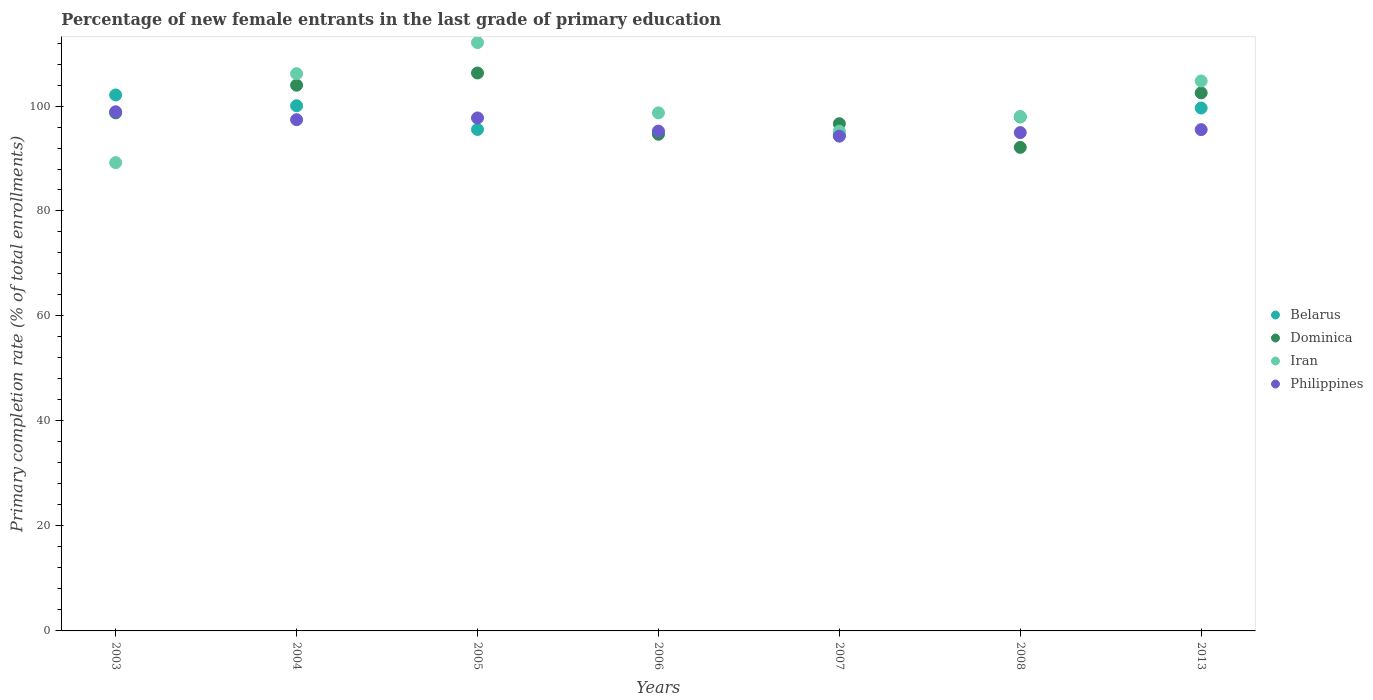How many different coloured dotlines are there?
Keep it short and to the point. 4. Is the number of dotlines equal to the number of legend labels?
Offer a terse response. Yes. What is the percentage of new female entrants in Dominica in 2013?
Offer a terse response. 102.5. Across all years, what is the maximum percentage of new female entrants in Belarus?
Your answer should be compact. 102.11. Across all years, what is the minimum percentage of new female entrants in Belarus?
Provide a succinct answer. 94.45. In which year was the percentage of new female entrants in Philippines minimum?
Make the answer very short. 2007. What is the total percentage of new female entrants in Dominica in the graph?
Offer a very short reply. 694.84. What is the difference between the percentage of new female entrants in Iran in 2004 and that in 2005?
Provide a short and direct response. -5.92. What is the difference between the percentage of new female entrants in Iran in 2013 and the percentage of new female entrants in Belarus in 2003?
Your response must be concise. 2.67. What is the average percentage of new female entrants in Dominica per year?
Your answer should be compact. 99.26. In the year 2013, what is the difference between the percentage of new female entrants in Iran and percentage of new female entrants in Philippines?
Provide a succinct answer. 9.27. In how many years, is the percentage of new female entrants in Dominica greater than 28 %?
Give a very brief answer. 7. What is the ratio of the percentage of new female entrants in Dominica in 2006 to that in 2013?
Ensure brevity in your answer.  0.92. Is the difference between the percentage of new female entrants in Iran in 2004 and 2007 greater than the difference between the percentage of new female entrants in Philippines in 2004 and 2007?
Provide a succinct answer. Yes. What is the difference between the highest and the second highest percentage of new female entrants in Iran?
Your response must be concise. 5.92. What is the difference between the highest and the lowest percentage of new female entrants in Belarus?
Offer a very short reply. 7.65. In how many years, is the percentage of new female entrants in Philippines greater than the average percentage of new female entrants in Philippines taken over all years?
Provide a short and direct response. 3. Is the sum of the percentage of new female entrants in Philippines in 2004 and 2007 greater than the maximum percentage of new female entrants in Iran across all years?
Offer a terse response. Yes. Is it the case that in every year, the sum of the percentage of new female entrants in Philippines and percentage of new female entrants in Belarus  is greater than the percentage of new female entrants in Iran?
Offer a terse response. Yes. How many dotlines are there?
Keep it short and to the point. 4. Are the values on the major ticks of Y-axis written in scientific E-notation?
Provide a succinct answer. No. How are the legend labels stacked?
Provide a short and direct response. Vertical. What is the title of the graph?
Ensure brevity in your answer.  Percentage of new female entrants in the last grade of primary education. Does "Belize" appear as one of the legend labels in the graph?
Keep it short and to the point. No. What is the label or title of the Y-axis?
Ensure brevity in your answer.  Primary completion rate (% of total enrollments). What is the Primary completion rate (% of total enrollments) of Belarus in 2003?
Your answer should be compact. 102.11. What is the Primary completion rate (% of total enrollments) of Dominica in 2003?
Ensure brevity in your answer.  98.7. What is the Primary completion rate (% of total enrollments) in Iran in 2003?
Your answer should be very brief. 89.22. What is the Primary completion rate (% of total enrollments) in Philippines in 2003?
Offer a very short reply. 98.9. What is the Primary completion rate (% of total enrollments) of Belarus in 2004?
Keep it short and to the point. 100.05. What is the Primary completion rate (% of total enrollments) of Dominica in 2004?
Your answer should be very brief. 103.97. What is the Primary completion rate (% of total enrollments) of Iran in 2004?
Keep it short and to the point. 106.16. What is the Primary completion rate (% of total enrollments) of Philippines in 2004?
Your answer should be very brief. 97.39. What is the Primary completion rate (% of total enrollments) in Belarus in 2005?
Keep it short and to the point. 95.53. What is the Primary completion rate (% of total enrollments) of Dominica in 2005?
Provide a succinct answer. 106.29. What is the Primary completion rate (% of total enrollments) of Iran in 2005?
Provide a short and direct response. 112.09. What is the Primary completion rate (% of total enrollments) in Philippines in 2005?
Your response must be concise. 97.73. What is the Primary completion rate (% of total enrollments) in Belarus in 2006?
Keep it short and to the point. 94.92. What is the Primary completion rate (% of total enrollments) in Dominica in 2006?
Keep it short and to the point. 94.62. What is the Primary completion rate (% of total enrollments) of Iran in 2006?
Offer a terse response. 98.69. What is the Primary completion rate (% of total enrollments) of Philippines in 2006?
Give a very brief answer. 95.22. What is the Primary completion rate (% of total enrollments) in Belarus in 2007?
Your response must be concise. 94.45. What is the Primary completion rate (% of total enrollments) in Dominica in 2007?
Provide a succinct answer. 96.63. What is the Primary completion rate (% of total enrollments) in Iran in 2007?
Ensure brevity in your answer.  95.21. What is the Primary completion rate (% of total enrollments) in Philippines in 2007?
Ensure brevity in your answer.  94.26. What is the Primary completion rate (% of total enrollments) of Belarus in 2008?
Provide a short and direct response. 97.92. What is the Primary completion rate (% of total enrollments) of Dominica in 2008?
Your answer should be compact. 92.12. What is the Primary completion rate (% of total enrollments) of Iran in 2008?
Your answer should be compact. 98. What is the Primary completion rate (% of total enrollments) of Philippines in 2008?
Provide a succinct answer. 94.93. What is the Primary completion rate (% of total enrollments) in Belarus in 2013?
Offer a terse response. 99.62. What is the Primary completion rate (% of total enrollments) in Dominica in 2013?
Give a very brief answer. 102.5. What is the Primary completion rate (% of total enrollments) in Iran in 2013?
Provide a succinct answer. 104.77. What is the Primary completion rate (% of total enrollments) of Philippines in 2013?
Offer a terse response. 95.5. Across all years, what is the maximum Primary completion rate (% of total enrollments) of Belarus?
Your answer should be compact. 102.11. Across all years, what is the maximum Primary completion rate (% of total enrollments) of Dominica?
Offer a very short reply. 106.29. Across all years, what is the maximum Primary completion rate (% of total enrollments) of Iran?
Make the answer very short. 112.09. Across all years, what is the maximum Primary completion rate (% of total enrollments) in Philippines?
Ensure brevity in your answer.  98.9. Across all years, what is the minimum Primary completion rate (% of total enrollments) in Belarus?
Keep it short and to the point. 94.45. Across all years, what is the minimum Primary completion rate (% of total enrollments) in Dominica?
Ensure brevity in your answer.  92.12. Across all years, what is the minimum Primary completion rate (% of total enrollments) in Iran?
Your response must be concise. 89.22. Across all years, what is the minimum Primary completion rate (% of total enrollments) of Philippines?
Make the answer very short. 94.26. What is the total Primary completion rate (% of total enrollments) in Belarus in the graph?
Ensure brevity in your answer.  684.59. What is the total Primary completion rate (% of total enrollments) of Dominica in the graph?
Make the answer very short. 694.84. What is the total Primary completion rate (% of total enrollments) in Iran in the graph?
Make the answer very short. 704.14. What is the total Primary completion rate (% of total enrollments) in Philippines in the graph?
Keep it short and to the point. 673.94. What is the difference between the Primary completion rate (% of total enrollments) of Belarus in 2003 and that in 2004?
Your answer should be very brief. 2.06. What is the difference between the Primary completion rate (% of total enrollments) in Dominica in 2003 and that in 2004?
Offer a very short reply. -5.27. What is the difference between the Primary completion rate (% of total enrollments) of Iran in 2003 and that in 2004?
Provide a succinct answer. -16.95. What is the difference between the Primary completion rate (% of total enrollments) of Philippines in 2003 and that in 2004?
Give a very brief answer. 1.51. What is the difference between the Primary completion rate (% of total enrollments) of Belarus in 2003 and that in 2005?
Your response must be concise. 6.57. What is the difference between the Primary completion rate (% of total enrollments) in Dominica in 2003 and that in 2005?
Offer a very short reply. -7.59. What is the difference between the Primary completion rate (% of total enrollments) in Iran in 2003 and that in 2005?
Your response must be concise. -22.87. What is the difference between the Primary completion rate (% of total enrollments) of Philippines in 2003 and that in 2005?
Give a very brief answer. 1.17. What is the difference between the Primary completion rate (% of total enrollments) in Belarus in 2003 and that in 2006?
Make the answer very short. 7.19. What is the difference between the Primary completion rate (% of total enrollments) of Dominica in 2003 and that in 2006?
Your response must be concise. 4.08. What is the difference between the Primary completion rate (% of total enrollments) of Iran in 2003 and that in 2006?
Your response must be concise. -9.48. What is the difference between the Primary completion rate (% of total enrollments) of Philippines in 2003 and that in 2006?
Your answer should be compact. 3.68. What is the difference between the Primary completion rate (% of total enrollments) of Belarus in 2003 and that in 2007?
Your answer should be compact. 7.65. What is the difference between the Primary completion rate (% of total enrollments) of Dominica in 2003 and that in 2007?
Give a very brief answer. 2.07. What is the difference between the Primary completion rate (% of total enrollments) of Iran in 2003 and that in 2007?
Provide a short and direct response. -5.99. What is the difference between the Primary completion rate (% of total enrollments) of Philippines in 2003 and that in 2007?
Offer a terse response. 4.64. What is the difference between the Primary completion rate (% of total enrollments) of Belarus in 2003 and that in 2008?
Offer a terse response. 4.19. What is the difference between the Primary completion rate (% of total enrollments) in Dominica in 2003 and that in 2008?
Make the answer very short. 6.58. What is the difference between the Primary completion rate (% of total enrollments) in Iran in 2003 and that in 2008?
Provide a short and direct response. -8.79. What is the difference between the Primary completion rate (% of total enrollments) in Philippines in 2003 and that in 2008?
Offer a very short reply. 3.97. What is the difference between the Primary completion rate (% of total enrollments) of Belarus in 2003 and that in 2013?
Ensure brevity in your answer.  2.49. What is the difference between the Primary completion rate (% of total enrollments) in Dominica in 2003 and that in 2013?
Your answer should be compact. -3.81. What is the difference between the Primary completion rate (% of total enrollments) in Iran in 2003 and that in 2013?
Make the answer very short. -15.56. What is the difference between the Primary completion rate (% of total enrollments) in Philippines in 2003 and that in 2013?
Offer a very short reply. 3.4. What is the difference between the Primary completion rate (% of total enrollments) in Belarus in 2004 and that in 2005?
Your answer should be very brief. 4.51. What is the difference between the Primary completion rate (% of total enrollments) of Dominica in 2004 and that in 2005?
Keep it short and to the point. -2.33. What is the difference between the Primary completion rate (% of total enrollments) in Iran in 2004 and that in 2005?
Provide a short and direct response. -5.92. What is the difference between the Primary completion rate (% of total enrollments) of Philippines in 2004 and that in 2005?
Give a very brief answer. -0.34. What is the difference between the Primary completion rate (% of total enrollments) in Belarus in 2004 and that in 2006?
Provide a succinct answer. 5.13. What is the difference between the Primary completion rate (% of total enrollments) of Dominica in 2004 and that in 2006?
Your response must be concise. 9.35. What is the difference between the Primary completion rate (% of total enrollments) of Iran in 2004 and that in 2006?
Your answer should be very brief. 7.47. What is the difference between the Primary completion rate (% of total enrollments) in Philippines in 2004 and that in 2006?
Keep it short and to the point. 2.17. What is the difference between the Primary completion rate (% of total enrollments) in Belarus in 2004 and that in 2007?
Your answer should be very brief. 5.59. What is the difference between the Primary completion rate (% of total enrollments) of Dominica in 2004 and that in 2007?
Offer a terse response. 7.33. What is the difference between the Primary completion rate (% of total enrollments) in Iran in 2004 and that in 2007?
Offer a very short reply. 10.96. What is the difference between the Primary completion rate (% of total enrollments) in Philippines in 2004 and that in 2007?
Your answer should be compact. 3.14. What is the difference between the Primary completion rate (% of total enrollments) of Belarus in 2004 and that in 2008?
Give a very brief answer. 2.13. What is the difference between the Primary completion rate (% of total enrollments) in Dominica in 2004 and that in 2008?
Make the answer very short. 11.84. What is the difference between the Primary completion rate (% of total enrollments) of Iran in 2004 and that in 2008?
Keep it short and to the point. 8.16. What is the difference between the Primary completion rate (% of total enrollments) in Philippines in 2004 and that in 2008?
Your answer should be very brief. 2.46. What is the difference between the Primary completion rate (% of total enrollments) in Belarus in 2004 and that in 2013?
Offer a terse response. 0.43. What is the difference between the Primary completion rate (% of total enrollments) of Dominica in 2004 and that in 2013?
Provide a short and direct response. 1.46. What is the difference between the Primary completion rate (% of total enrollments) of Iran in 2004 and that in 2013?
Your answer should be compact. 1.39. What is the difference between the Primary completion rate (% of total enrollments) in Philippines in 2004 and that in 2013?
Provide a short and direct response. 1.89. What is the difference between the Primary completion rate (% of total enrollments) of Belarus in 2005 and that in 2006?
Your answer should be very brief. 0.61. What is the difference between the Primary completion rate (% of total enrollments) in Dominica in 2005 and that in 2006?
Ensure brevity in your answer.  11.68. What is the difference between the Primary completion rate (% of total enrollments) in Iran in 2005 and that in 2006?
Your response must be concise. 13.39. What is the difference between the Primary completion rate (% of total enrollments) in Philippines in 2005 and that in 2006?
Your response must be concise. 2.51. What is the difference between the Primary completion rate (% of total enrollments) in Belarus in 2005 and that in 2007?
Offer a terse response. 1.08. What is the difference between the Primary completion rate (% of total enrollments) in Dominica in 2005 and that in 2007?
Offer a terse response. 9.66. What is the difference between the Primary completion rate (% of total enrollments) of Iran in 2005 and that in 2007?
Give a very brief answer. 16.88. What is the difference between the Primary completion rate (% of total enrollments) in Philippines in 2005 and that in 2007?
Provide a short and direct response. 3.47. What is the difference between the Primary completion rate (% of total enrollments) in Belarus in 2005 and that in 2008?
Your answer should be very brief. -2.39. What is the difference between the Primary completion rate (% of total enrollments) in Dominica in 2005 and that in 2008?
Provide a short and direct response. 14.17. What is the difference between the Primary completion rate (% of total enrollments) in Iran in 2005 and that in 2008?
Keep it short and to the point. 14.08. What is the difference between the Primary completion rate (% of total enrollments) in Philippines in 2005 and that in 2008?
Keep it short and to the point. 2.79. What is the difference between the Primary completion rate (% of total enrollments) in Belarus in 2005 and that in 2013?
Offer a terse response. -4.08. What is the difference between the Primary completion rate (% of total enrollments) in Dominica in 2005 and that in 2013?
Your answer should be very brief. 3.79. What is the difference between the Primary completion rate (% of total enrollments) in Iran in 2005 and that in 2013?
Ensure brevity in your answer.  7.31. What is the difference between the Primary completion rate (% of total enrollments) of Philippines in 2005 and that in 2013?
Your response must be concise. 2.23. What is the difference between the Primary completion rate (% of total enrollments) of Belarus in 2006 and that in 2007?
Your answer should be very brief. 0.47. What is the difference between the Primary completion rate (% of total enrollments) in Dominica in 2006 and that in 2007?
Offer a very short reply. -2.01. What is the difference between the Primary completion rate (% of total enrollments) of Iran in 2006 and that in 2007?
Your answer should be very brief. 3.49. What is the difference between the Primary completion rate (% of total enrollments) in Philippines in 2006 and that in 2007?
Your response must be concise. 0.96. What is the difference between the Primary completion rate (% of total enrollments) in Belarus in 2006 and that in 2008?
Make the answer very short. -3. What is the difference between the Primary completion rate (% of total enrollments) of Dominica in 2006 and that in 2008?
Keep it short and to the point. 2.5. What is the difference between the Primary completion rate (% of total enrollments) of Iran in 2006 and that in 2008?
Provide a succinct answer. 0.69. What is the difference between the Primary completion rate (% of total enrollments) in Philippines in 2006 and that in 2008?
Ensure brevity in your answer.  0.29. What is the difference between the Primary completion rate (% of total enrollments) of Belarus in 2006 and that in 2013?
Your answer should be compact. -4.7. What is the difference between the Primary completion rate (% of total enrollments) of Dominica in 2006 and that in 2013?
Offer a very short reply. -7.89. What is the difference between the Primary completion rate (% of total enrollments) in Iran in 2006 and that in 2013?
Offer a very short reply. -6.08. What is the difference between the Primary completion rate (% of total enrollments) in Philippines in 2006 and that in 2013?
Ensure brevity in your answer.  -0.28. What is the difference between the Primary completion rate (% of total enrollments) in Belarus in 2007 and that in 2008?
Ensure brevity in your answer.  -3.47. What is the difference between the Primary completion rate (% of total enrollments) of Dominica in 2007 and that in 2008?
Provide a short and direct response. 4.51. What is the difference between the Primary completion rate (% of total enrollments) in Iran in 2007 and that in 2008?
Give a very brief answer. -2.8. What is the difference between the Primary completion rate (% of total enrollments) in Philippines in 2007 and that in 2008?
Make the answer very short. -0.68. What is the difference between the Primary completion rate (% of total enrollments) in Belarus in 2007 and that in 2013?
Your answer should be compact. -5.16. What is the difference between the Primary completion rate (% of total enrollments) in Dominica in 2007 and that in 2013?
Make the answer very short. -5.87. What is the difference between the Primary completion rate (% of total enrollments) of Iran in 2007 and that in 2013?
Your answer should be compact. -9.57. What is the difference between the Primary completion rate (% of total enrollments) of Philippines in 2007 and that in 2013?
Provide a short and direct response. -1.24. What is the difference between the Primary completion rate (% of total enrollments) in Belarus in 2008 and that in 2013?
Offer a very short reply. -1.7. What is the difference between the Primary completion rate (% of total enrollments) of Dominica in 2008 and that in 2013?
Offer a very short reply. -10.38. What is the difference between the Primary completion rate (% of total enrollments) of Iran in 2008 and that in 2013?
Your answer should be compact. -6.77. What is the difference between the Primary completion rate (% of total enrollments) of Philippines in 2008 and that in 2013?
Your answer should be compact. -0.57. What is the difference between the Primary completion rate (% of total enrollments) in Belarus in 2003 and the Primary completion rate (% of total enrollments) in Dominica in 2004?
Offer a very short reply. -1.86. What is the difference between the Primary completion rate (% of total enrollments) in Belarus in 2003 and the Primary completion rate (% of total enrollments) in Iran in 2004?
Give a very brief answer. -4.06. What is the difference between the Primary completion rate (% of total enrollments) of Belarus in 2003 and the Primary completion rate (% of total enrollments) of Philippines in 2004?
Your answer should be compact. 4.71. What is the difference between the Primary completion rate (% of total enrollments) of Dominica in 2003 and the Primary completion rate (% of total enrollments) of Iran in 2004?
Keep it short and to the point. -7.46. What is the difference between the Primary completion rate (% of total enrollments) of Dominica in 2003 and the Primary completion rate (% of total enrollments) of Philippines in 2004?
Provide a succinct answer. 1.31. What is the difference between the Primary completion rate (% of total enrollments) in Iran in 2003 and the Primary completion rate (% of total enrollments) in Philippines in 2004?
Ensure brevity in your answer.  -8.18. What is the difference between the Primary completion rate (% of total enrollments) of Belarus in 2003 and the Primary completion rate (% of total enrollments) of Dominica in 2005?
Your answer should be very brief. -4.19. What is the difference between the Primary completion rate (% of total enrollments) in Belarus in 2003 and the Primary completion rate (% of total enrollments) in Iran in 2005?
Your response must be concise. -9.98. What is the difference between the Primary completion rate (% of total enrollments) of Belarus in 2003 and the Primary completion rate (% of total enrollments) of Philippines in 2005?
Offer a terse response. 4.38. What is the difference between the Primary completion rate (% of total enrollments) of Dominica in 2003 and the Primary completion rate (% of total enrollments) of Iran in 2005?
Your answer should be compact. -13.39. What is the difference between the Primary completion rate (% of total enrollments) in Dominica in 2003 and the Primary completion rate (% of total enrollments) in Philippines in 2005?
Ensure brevity in your answer.  0.97. What is the difference between the Primary completion rate (% of total enrollments) in Iran in 2003 and the Primary completion rate (% of total enrollments) in Philippines in 2005?
Offer a very short reply. -8.51. What is the difference between the Primary completion rate (% of total enrollments) in Belarus in 2003 and the Primary completion rate (% of total enrollments) in Dominica in 2006?
Give a very brief answer. 7.49. What is the difference between the Primary completion rate (% of total enrollments) of Belarus in 2003 and the Primary completion rate (% of total enrollments) of Iran in 2006?
Provide a succinct answer. 3.41. What is the difference between the Primary completion rate (% of total enrollments) in Belarus in 2003 and the Primary completion rate (% of total enrollments) in Philippines in 2006?
Your answer should be compact. 6.88. What is the difference between the Primary completion rate (% of total enrollments) of Dominica in 2003 and the Primary completion rate (% of total enrollments) of Iran in 2006?
Your answer should be very brief. 0.01. What is the difference between the Primary completion rate (% of total enrollments) in Dominica in 2003 and the Primary completion rate (% of total enrollments) in Philippines in 2006?
Offer a very short reply. 3.48. What is the difference between the Primary completion rate (% of total enrollments) of Iran in 2003 and the Primary completion rate (% of total enrollments) of Philippines in 2006?
Make the answer very short. -6.01. What is the difference between the Primary completion rate (% of total enrollments) in Belarus in 2003 and the Primary completion rate (% of total enrollments) in Dominica in 2007?
Provide a short and direct response. 5.47. What is the difference between the Primary completion rate (% of total enrollments) in Belarus in 2003 and the Primary completion rate (% of total enrollments) in Iran in 2007?
Offer a terse response. 6.9. What is the difference between the Primary completion rate (% of total enrollments) in Belarus in 2003 and the Primary completion rate (% of total enrollments) in Philippines in 2007?
Offer a terse response. 7.85. What is the difference between the Primary completion rate (% of total enrollments) in Dominica in 2003 and the Primary completion rate (% of total enrollments) in Iran in 2007?
Offer a terse response. 3.49. What is the difference between the Primary completion rate (% of total enrollments) in Dominica in 2003 and the Primary completion rate (% of total enrollments) in Philippines in 2007?
Your answer should be compact. 4.44. What is the difference between the Primary completion rate (% of total enrollments) in Iran in 2003 and the Primary completion rate (% of total enrollments) in Philippines in 2007?
Your answer should be very brief. -5.04. What is the difference between the Primary completion rate (% of total enrollments) in Belarus in 2003 and the Primary completion rate (% of total enrollments) in Dominica in 2008?
Your answer should be very brief. 9.98. What is the difference between the Primary completion rate (% of total enrollments) in Belarus in 2003 and the Primary completion rate (% of total enrollments) in Iran in 2008?
Offer a very short reply. 4.1. What is the difference between the Primary completion rate (% of total enrollments) in Belarus in 2003 and the Primary completion rate (% of total enrollments) in Philippines in 2008?
Make the answer very short. 7.17. What is the difference between the Primary completion rate (% of total enrollments) in Dominica in 2003 and the Primary completion rate (% of total enrollments) in Iran in 2008?
Your answer should be compact. 0.69. What is the difference between the Primary completion rate (% of total enrollments) of Dominica in 2003 and the Primary completion rate (% of total enrollments) of Philippines in 2008?
Make the answer very short. 3.77. What is the difference between the Primary completion rate (% of total enrollments) of Iran in 2003 and the Primary completion rate (% of total enrollments) of Philippines in 2008?
Provide a succinct answer. -5.72. What is the difference between the Primary completion rate (% of total enrollments) of Belarus in 2003 and the Primary completion rate (% of total enrollments) of Dominica in 2013?
Give a very brief answer. -0.4. What is the difference between the Primary completion rate (% of total enrollments) in Belarus in 2003 and the Primary completion rate (% of total enrollments) in Iran in 2013?
Keep it short and to the point. -2.67. What is the difference between the Primary completion rate (% of total enrollments) in Belarus in 2003 and the Primary completion rate (% of total enrollments) in Philippines in 2013?
Offer a very short reply. 6.6. What is the difference between the Primary completion rate (% of total enrollments) of Dominica in 2003 and the Primary completion rate (% of total enrollments) of Iran in 2013?
Your answer should be compact. -6.08. What is the difference between the Primary completion rate (% of total enrollments) in Dominica in 2003 and the Primary completion rate (% of total enrollments) in Philippines in 2013?
Ensure brevity in your answer.  3.2. What is the difference between the Primary completion rate (% of total enrollments) in Iran in 2003 and the Primary completion rate (% of total enrollments) in Philippines in 2013?
Your answer should be compact. -6.29. What is the difference between the Primary completion rate (% of total enrollments) in Belarus in 2004 and the Primary completion rate (% of total enrollments) in Dominica in 2005?
Provide a short and direct response. -6.25. What is the difference between the Primary completion rate (% of total enrollments) of Belarus in 2004 and the Primary completion rate (% of total enrollments) of Iran in 2005?
Provide a short and direct response. -12.04. What is the difference between the Primary completion rate (% of total enrollments) in Belarus in 2004 and the Primary completion rate (% of total enrollments) in Philippines in 2005?
Offer a very short reply. 2.32. What is the difference between the Primary completion rate (% of total enrollments) in Dominica in 2004 and the Primary completion rate (% of total enrollments) in Iran in 2005?
Offer a very short reply. -8.12. What is the difference between the Primary completion rate (% of total enrollments) of Dominica in 2004 and the Primary completion rate (% of total enrollments) of Philippines in 2005?
Offer a terse response. 6.24. What is the difference between the Primary completion rate (% of total enrollments) in Iran in 2004 and the Primary completion rate (% of total enrollments) in Philippines in 2005?
Ensure brevity in your answer.  8.43. What is the difference between the Primary completion rate (% of total enrollments) in Belarus in 2004 and the Primary completion rate (% of total enrollments) in Dominica in 2006?
Your answer should be very brief. 5.43. What is the difference between the Primary completion rate (% of total enrollments) of Belarus in 2004 and the Primary completion rate (% of total enrollments) of Iran in 2006?
Give a very brief answer. 1.35. What is the difference between the Primary completion rate (% of total enrollments) in Belarus in 2004 and the Primary completion rate (% of total enrollments) in Philippines in 2006?
Provide a succinct answer. 4.82. What is the difference between the Primary completion rate (% of total enrollments) of Dominica in 2004 and the Primary completion rate (% of total enrollments) of Iran in 2006?
Provide a succinct answer. 5.27. What is the difference between the Primary completion rate (% of total enrollments) in Dominica in 2004 and the Primary completion rate (% of total enrollments) in Philippines in 2006?
Your answer should be compact. 8.74. What is the difference between the Primary completion rate (% of total enrollments) in Iran in 2004 and the Primary completion rate (% of total enrollments) in Philippines in 2006?
Ensure brevity in your answer.  10.94. What is the difference between the Primary completion rate (% of total enrollments) of Belarus in 2004 and the Primary completion rate (% of total enrollments) of Dominica in 2007?
Your answer should be compact. 3.41. What is the difference between the Primary completion rate (% of total enrollments) in Belarus in 2004 and the Primary completion rate (% of total enrollments) in Iran in 2007?
Your response must be concise. 4.84. What is the difference between the Primary completion rate (% of total enrollments) in Belarus in 2004 and the Primary completion rate (% of total enrollments) in Philippines in 2007?
Offer a terse response. 5.79. What is the difference between the Primary completion rate (% of total enrollments) of Dominica in 2004 and the Primary completion rate (% of total enrollments) of Iran in 2007?
Keep it short and to the point. 8.76. What is the difference between the Primary completion rate (% of total enrollments) in Dominica in 2004 and the Primary completion rate (% of total enrollments) in Philippines in 2007?
Provide a succinct answer. 9.71. What is the difference between the Primary completion rate (% of total enrollments) in Iran in 2004 and the Primary completion rate (% of total enrollments) in Philippines in 2007?
Your response must be concise. 11.91. What is the difference between the Primary completion rate (% of total enrollments) of Belarus in 2004 and the Primary completion rate (% of total enrollments) of Dominica in 2008?
Ensure brevity in your answer.  7.93. What is the difference between the Primary completion rate (% of total enrollments) in Belarus in 2004 and the Primary completion rate (% of total enrollments) in Iran in 2008?
Offer a very short reply. 2.04. What is the difference between the Primary completion rate (% of total enrollments) of Belarus in 2004 and the Primary completion rate (% of total enrollments) of Philippines in 2008?
Make the answer very short. 5.11. What is the difference between the Primary completion rate (% of total enrollments) of Dominica in 2004 and the Primary completion rate (% of total enrollments) of Iran in 2008?
Keep it short and to the point. 5.96. What is the difference between the Primary completion rate (% of total enrollments) in Dominica in 2004 and the Primary completion rate (% of total enrollments) in Philippines in 2008?
Your response must be concise. 9.03. What is the difference between the Primary completion rate (% of total enrollments) in Iran in 2004 and the Primary completion rate (% of total enrollments) in Philippines in 2008?
Your response must be concise. 11.23. What is the difference between the Primary completion rate (% of total enrollments) in Belarus in 2004 and the Primary completion rate (% of total enrollments) in Dominica in 2013?
Provide a succinct answer. -2.46. What is the difference between the Primary completion rate (% of total enrollments) of Belarus in 2004 and the Primary completion rate (% of total enrollments) of Iran in 2013?
Keep it short and to the point. -4.73. What is the difference between the Primary completion rate (% of total enrollments) of Belarus in 2004 and the Primary completion rate (% of total enrollments) of Philippines in 2013?
Your response must be concise. 4.55. What is the difference between the Primary completion rate (% of total enrollments) in Dominica in 2004 and the Primary completion rate (% of total enrollments) in Iran in 2013?
Your answer should be very brief. -0.81. What is the difference between the Primary completion rate (% of total enrollments) in Dominica in 2004 and the Primary completion rate (% of total enrollments) in Philippines in 2013?
Ensure brevity in your answer.  8.46. What is the difference between the Primary completion rate (% of total enrollments) of Iran in 2004 and the Primary completion rate (% of total enrollments) of Philippines in 2013?
Keep it short and to the point. 10.66. What is the difference between the Primary completion rate (% of total enrollments) in Belarus in 2005 and the Primary completion rate (% of total enrollments) in Dominica in 2006?
Provide a short and direct response. 0.92. What is the difference between the Primary completion rate (% of total enrollments) of Belarus in 2005 and the Primary completion rate (% of total enrollments) of Iran in 2006?
Give a very brief answer. -3.16. What is the difference between the Primary completion rate (% of total enrollments) in Belarus in 2005 and the Primary completion rate (% of total enrollments) in Philippines in 2006?
Offer a very short reply. 0.31. What is the difference between the Primary completion rate (% of total enrollments) in Dominica in 2005 and the Primary completion rate (% of total enrollments) in Iran in 2006?
Give a very brief answer. 7.6. What is the difference between the Primary completion rate (% of total enrollments) of Dominica in 2005 and the Primary completion rate (% of total enrollments) of Philippines in 2006?
Provide a succinct answer. 11.07. What is the difference between the Primary completion rate (% of total enrollments) of Iran in 2005 and the Primary completion rate (% of total enrollments) of Philippines in 2006?
Your answer should be very brief. 16.86. What is the difference between the Primary completion rate (% of total enrollments) of Belarus in 2005 and the Primary completion rate (% of total enrollments) of Dominica in 2007?
Offer a very short reply. -1.1. What is the difference between the Primary completion rate (% of total enrollments) of Belarus in 2005 and the Primary completion rate (% of total enrollments) of Iran in 2007?
Give a very brief answer. 0.33. What is the difference between the Primary completion rate (% of total enrollments) in Belarus in 2005 and the Primary completion rate (% of total enrollments) in Philippines in 2007?
Offer a very short reply. 1.28. What is the difference between the Primary completion rate (% of total enrollments) in Dominica in 2005 and the Primary completion rate (% of total enrollments) in Iran in 2007?
Your response must be concise. 11.09. What is the difference between the Primary completion rate (% of total enrollments) of Dominica in 2005 and the Primary completion rate (% of total enrollments) of Philippines in 2007?
Ensure brevity in your answer.  12.04. What is the difference between the Primary completion rate (% of total enrollments) in Iran in 2005 and the Primary completion rate (% of total enrollments) in Philippines in 2007?
Keep it short and to the point. 17.83. What is the difference between the Primary completion rate (% of total enrollments) in Belarus in 2005 and the Primary completion rate (% of total enrollments) in Dominica in 2008?
Make the answer very short. 3.41. What is the difference between the Primary completion rate (% of total enrollments) in Belarus in 2005 and the Primary completion rate (% of total enrollments) in Iran in 2008?
Your answer should be compact. -2.47. What is the difference between the Primary completion rate (% of total enrollments) of Belarus in 2005 and the Primary completion rate (% of total enrollments) of Philippines in 2008?
Your response must be concise. 0.6. What is the difference between the Primary completion rate (% of total enrollments) of Dominica in 2005 and the Primary completion rate (% of total enrollments) of Iran in 2008?
Give a very brief answer. 8.29. What is the difference between the Primary completion rate (% of total enrollments) of Dominica in 2005 and the Primary completion rate (% of total enrollments) of Philippines in 2008?
Your answer should be very brief. 11.36. What is the difference between the Primary completion rate (% of total enrollments) in Iran in 2005 and the Primary completion rate (% of total enrollments) in Philippines in 2008?
Keep it short and to the point. 17.15. What is the difference between the Primary completion rate (% of total enrollments) in Belarus in 2005 and the Primary completion rate (% of total enrollments) in Dominica in 2013?
Make the answer very short. -6.97. What is the difference between the Primary completion rate (% of total enrollments) of Belarus in 2005 and the Primary completion rate (% of total enrollments) of Iran in 2013?
Make the answer very short. -9.24. What is the difference between the Primary completion rate (% of total enrollments) of Belarus in 2005 and the Primary completion rate (% of total enrollments) of Philippines in 2013?
Make the answer very short. 0.03. What is the difference between the Primary completion rate (% of total enrollments) of Dominica in 2005 and the Primary completion rate (% of total enrollments) of Iran in 2013?
Your answer should be compact. 1.52. What is the difference between the Primary completion rate (% of total enrollments) in Dominica in 2005 and the Primary completion rate (% of total enrollments) in Philippines in 2013?
Make the answer very short. 10.79. What is the difference between the Primary completion rate (% of total enrollments) of Iran in 2005 and the Primary completion rate (% of total enrollments) of Philippines in 2013?
Provide a short and direct response. 16.58. What is the difference between the Primary completion rate (% of total enrollments) of Belarus in 2006 and the Primary completion rate (% of total enrollments) of Dominica in 2007?
Your answer should be very brief. -1.71. What is the difference between the Primary completion rate (% of total enrollments) in Belarus in 2006 and the Primary completion rate (% of total enrollments) in Iran in 2007?
Your answer should be very brief. -0.29. What is the difference between the Primary completion rate (% of total enrollments) in Belarus in 2006 and the Primary completion rate (% of total enrollments) in Philippines in 2007?
Offer a very short reply. 0.66. What is the difference between the Primary completion rate (% of total enrollments) in Dominica in 2006 and the Primary completion rate (% of total enrollments) in Iran in 2007?
Keep it short and to the point. -0.59. What is the difference between the Primary completion rate (% of total enrollments) of Dominica in 2006 and the Primary completion rate (% of total enrollments) of Philippines in 2007?
Your answer should be compact. 0.36. What is the difference between the Primary completion rate (% of total enrollments) of Iran in 2006 and the Primary completion rate (% of total enrollments) of Philippines in 2007?
Keep it short and to the point. 4.44. What is the difference between the Primary completion rate (% of total enrollments) in Belarus in 2006 and the Primary completion rate (% of total enrollments) in Dominica in 2008?
Make the answer very short. 2.8. What is the difference between the Primary completion rate (% of total enrollments) of Belarus in 2006 and the Primary completion rate (% of total enrollments) of Iran in 2008?
Offer a very short reply. -3.09. What is the difference between the Primary completion rate (% of total enrollments) in Belarus in 2006 and the Primary completion rate (% of total enrollments) in Philippines in 2008?
Give a very brief answer. -0.01. What is the difference between the Primary completion rate (% of total enrollments) in Dominica in 2006 and the Primary completion rate (% of total enrollments) in Iran in 2008?
Keep it short and to the point. -3.39. What is the difference between the Primary completion rate (% of total enrollments) in Dominica in 2006 and the Primary completion rate (% of total enrollments) in Philippines in 2008?
Your answer should be very brief. -0.32. What is the difference between the Primary completion rate (% of total enrollments) of Iran in 2006 and the Primary completion rate (% of total enrollments) of Philippines in 2008?
Make the answer very short. 3.76. What is the difference between the Primary completion rate (% of total enrollments) of Belarus in 2006 and the Primary completion rate (% of total enrollments) of Dominica in 2013?
Offer a very short reply. -7.58. What is the difference between the Primary completion rate (% of total enrollments) in Belarus in 2006 and the Primary completion rate (% of total enrollments) in Iran in 2013?
Make the answer very short. -9.85. What is the difference between the Primary completion rate (% of total enrollments) of Belarus in 2006 and the Primary completion rate (% of total enrollments) of Philippines in 2013?
Provide a succinct answer. -0.58. What is the difference between the Primary completion rate (% of total enrollments) in Dominica in 2006 and the Primary completion rate (% of total enrollments) in Iran in 2013?
Provide a succinct answer. -10.16. What is the difference between the Primary completion rate (% of total enrollments) in Dominica in 2006 and the Primary completion rate (% of total enrollments) in Philippines in 2013?
Provide a succinct answer. -0.88. What is the difference between the Primary completion rate (% of total enrollments) of Iran in 2006 and the Primary completion rate (% of total enrollments) of Philippines in 2013?
Make the answer very short. 3.19. What is the difference between the Primary completion rate (% of total enrollments) of Belarus in 2007 and the Primary completion rate (% of total enrollments) of Dominica in 2008?
Give a very brief answer. 2.33. What is the difference between the Primary completion rate (% of total enrollments) in Belarus in 2007 and the Primary completion rate (% of total enrollments) in Iran in 2008?
Provide a short and direct response. -3.55. What is the difference between the Primary completion rate (% of total enrollments) in Belarus in 2007 and the Primary completion rate (% of total enrollments) in Philippines in 2008?
Give a very brief answer. -0.48. What is the difference between the Primary completion rate (% of total enrollments) in Dominica in 2007 and the Primary completion rate (% of total enrollments) in Iran in 2008?
Your answer should be compact. -1.37. What is the difference between the Primary completion rate (% of total enrollments) in Dominica in 2007 and the Primary completion rate (% of total enrollments) in Philippines in 2008?
Your answer should be compact. 1.7. What is the difference between the Primary completion rate (% of total enrollments) of Iran in 2007 and the Primary completion rate (% of total enrollments) of Philippines in 2008?
Your answer should be very brief. 0.27. What is the difference between the Primary completion rate (% of total enrollments) in Belarus in 2007 and the Primary completion rate (% of total enrollments) in Dominica in 2013?
Keep it short and to the point. -8.05. What is the difference between the Primary completion rate (% of total enrollments) of Belarus in 2007 and the Primary completion rate (% of total enrollments) of Iran in 2013?
Make the answer very short. -10.32. What is the difference between the Primary completion rate (% of total enrollments) in Belarus in 2007 and the Primary completion rate (% of total enrollments) in Philippines in 2013?
Keep it short and to the point. -1.05. What is the difference between the Primary completion rate (% of total enrollments) of Dominica in 2007 and the Primary completion rate (% of total enrollments) of Iran in 2013?
Keep it short and to the point. -8.14. What is the difference between the Primary completion rate (% of total enrollments) of Dominica in 2007 and the Primary completion rate (% of total enrollments) of Philippines in 2013?
Keep it short and to the point. 1.13. What is the difference between the Primary completion rate (% of total enrollments) of Iran in 2007 and the Primary completion rate (% of total enrollments) of Philippines in 2013?
Your response must be concise. -0.3. What is the difference between the Primary completion rate (% of total enrollments) of Belarus in 2008 and the Primary completion rate (% of total enrollments) of Dominica in 2013?
Your response must be concise. -4.59. What is the difference between the Primary completion rate (% of total enrollments) of Belarus in 2008 and the Primary completion rate (% of total enrollments) of Iran in 2013?
Give a very brief answer. -6.86. What is the difference between the Primary completion rate (% of total enrollments) in Belarus in 2008 and the Primary completion rate (% of total enrollments) in Philippines in 2013?
Your response must be concise. 2.42. What is the difference between the Primary completion rate (% of total enrollments) in Dominica in 2008 and the Primary completion rate (% of total enrollments) in Iran in 2013?
Ensure brevity in your answer.  -12.65. What is the difference between the Primary completion rate (% of total enrollments) in Dominica in 2008 and the Primary completion rate (% of total enrollments) in Philippines in 2013?
Keep it short and to the point. -3.38. What is the difference between the Primary completion rate (% of total enrollments) in Iran in 2008 and the Primary completion rate (% of total enrollments) in Philippines in 2013?
Provide a short and direct response. 2.5. What is the average Primary completion rate (% of total enrollments) of Belarus per year?
Ensure brevity in your answer.  97.8. What is the average Primary completion rate (% of total enrollments) of Dominica per year?
Provide a short and direct response. 99.26. What is the average Primary completion rate (% of total enrollments) of Iran per year?
Provide a short and direct response. 100.59. What is the average Primary completion rate (% of total enrollments) in Philippines per year?
Give a very brief answer. 96.28. In the year 2003, what is the difference between the Primary completion rate (% of total enrollments) in Belarus and Primary completion rate (% of total enrollments) in Dominica?
Your answer should be compact. 3.41. In the year 2003, what is the difference between the Primary completion rate (% of total enrollments) of Belarus and Primary completion rate (% of total enrollments) of Iran?
Provide a succinct answer. 12.89. In the year 2003, what is the difference between the Primary completion rate (% of total enrollments) of Belarus and Primary completion rate (% of total enrollments) of Philippines?
Make the answer very short. 3.21. In the year 2003, what is the difference between the Primary completion rate (% of total enrollments) of Dominica and Primary completion rate (% of total enrollments) of Iran?
Offer a very short reply. 9.48. In the year 2003, what is the difference between the Primary completion rate (% of total enrollments) in Dominica and Primary completion rate (% of total enrollments) in Philippines?
Provide a short and direct response. -0.2. In the year 2003, what is the difference between the Primary completion rate (% of total enrollments) in Iran and Primary completion rate (% of total enrollments) in Philippines?
Your answer should be compact. -9.68. In the year 2004, what is the difference between the Primary completion rate (% of total enrollments) of Belarus and Primary completion rate (% of total enrollments) of Dominica?
Your answer should be compact. -3.92. In the year 2004, what is the difference between the Primary completion rate (% of total enrollments) of Belarus and Primary completion rate (% of total enrollments) of Iran?
Ensure brevity in your answer.  -6.12. In the year 2004, what is the difference between the Primary completion rate (% of total enrollments) in Belarus and Primary completion rate (% of total enrollments) in Philippines?
Your answer should be compact. 2.65. In the year 2004, what is the difference between the Primary completion rate (% of total enrollments) in Dominica and Primary completion rate (% of total enrollments) in Iran?
Provide a short and direct response. -2.2. In the year 2004, what is the difference between the Primary completion rate (% of total enrollments) in Dominica and Primary completion rate (% of total enrollments) in Philippines?
Your response must be concise. 6.57. In the year 2004, what is the difference between the Primary completion rate (% of total enrollments) in Iran and Primary completion rate (% of total enrollments) in Philippines?
Your response must be concise. 8.77. In the year 2005, what is the difference between the Primary completion rate (% of total enrollments) in Belarus and Primary completion rate (% of total enrollments) in Dominica?
Your answer should be very brief. -10.76. In the year 2005, what is the difference between the Primary completion rate (% of total enrollments) of Belarus and Primary completion rate (% of total enrollments) of Iran?
Provide a succinct answer. -16.55. In the year 2005, what is the difference between the Primary completion rate (% of total enrollments) of Belarus and Primary completion rate (% of total enrollments) of Philippines?
Your answer should be very brief. -2.2. In the year 2005, what is the difference between the Primary completion rate (% of total enrollments) in Dominica and Primary completion rate (% of total enrollments) in Iran?
Keep it short and to the point. -5.79. In the year 2005, what is the difference between the Primary completion rate (% of total enrollments) of Dominica and Primary completion rate (% of total enrollments) of Philippines?
Your answer should be very brief. 8.56. In the year 2005, what is the difference between the Primary completion rate (% of total enrollments) in Iran and Primary completion rate (% of total enrollments) in Philippines?
Provide a succinct answer. 14.36. In the year 2006, what is the difference between the Primary completion rate (% of total enrollments) in Belarus and Primary completion rate (% of total enrollments) in Dominica?
Give a very brief answer. 0.3. In the year 2006, what is the difference between the Primary completion rate (% of total enrollments) in Belarus and Primary completion rate (% of total enrollments) in Iran?
Your answer should be compact. -3.77. In the year 2006, what is the difference between the Primary completion rate (% of total enrollments) in Belarus and Primary completion rate (% of total enrollments) in Philippines?
Provide a succinct answer. -0.3. In the year 2006, what is the difference between the Primary completion rate (% of total enrollments) of Dominica and Primary completion rate (% of total enrollments) of Iran?
Provide a short and direct response. -4.08. In the year 2006, what is the difference between the Primary completion rate (% of total enrollments) of Dominica and Primary completion rate (% of total enrollments) of Philippines?
Offer a terse response. -0.6. In the year 2006, what is the difference between the Primary completion rate (% of total enrollments) of Iran and Primary completion rate (% of total enrollments) of Philippines?
Provide a succinct answer. 3.47. In the year 2007, what is the difference between the Primary completion rate (% of total enrollments) in Belarus and Primary completion rate (% of total enrollments) in Dominica?
Make the answer very short. -2.18. In the year 2007, what is the difference between the Primary completion rate (% of total enrollments) of Belarus and Primary completion rate (% of total enrollments) of Iran?
Your answer should be compact. -0.75. In the year 2007, what is the difference between the Primary completion rate (% of total enrollments) in Belarus and Primary completion rate (% of total enrollments) in Philippines?
Keep it short and to the point. 0.2. In the year 2007, what is the difference between the Primary completion rate (% of total enrollments) of Dominica and Primary completion rate (% of total enrollments) of Iran?
Make the answer very short. 1.43. In the year 2007, what is the difference between the Primary completion rate (% of total enrollments) in Dominica and Primary completion rate (% of total enrollments) in Philippines?
Your response must be concise. 2.38. In the year 2007, what is the difference between the Primary completion rate (% of total enrollments) in Iran and Primary completion rate (% of total enrollments) in Philippines?
Offer a very short reply. 0.95. In the year 2008, what is the difference between the Primary completion rate (% of total enrollments) in Belarus and Primary completion rate (% of total enrollments) in Dominica?
Offer a very short reply. 5.8. In the year 2008, what is the difference between the Primary completion rate (% of total enrollments) of Belarus and Primary completion rate (% of total enrollments) of Iran?
Offer a very short reply. -0.09. In the year 2008, what is the difference between the Primary completion rate (% of total enrollments) of Belarus and Primary completion rate (% of total enrollments) of Philippines?
Ensure brevity in your answer.  2.98. In the year 2008, what is the difference between the Primary completion rate (% of total enrollments) in Dominica and Primary completion rate (% of total enrollments) in Iran?
Your answer should be very brief. -5.88. In the year 2008, what is the difference between the Primary completion rate (% of total enrollments) of Dominica and Primary completion rate (% of total enrollments) of Philippines?
Give a very brief answer. -2.81. In the year 2008, what is the difference between the Primary completion rate (% of total enrollments) in Iran and Primary completion rate (% of total enrollments) in Philippines?
Your response must be concise. 3.07. In the year 2013, what is the difference between the Primary completion rate (% of total enrollments) in Belarus and Primary completion rate (% of total enrollments) in Dominica?
Offer a terse response. -2.89. In the year 2013, what is the difference between the Primary completion rate (% of total enrollments) of Belarus and Primary completion rate (% of total enrollments) of Iran?
Provide a succinct answer. -5.16. In the year 2013, what is the difference between the Primary completion rate (% of total enrollments) of Belarus and Primary completion rate (% of total enrollments) of Philippines?
Ensure brevity in your answer.  4.11. In the year 2013, what is the difference between the Primary completion rate (% of total enrollments) in Dominica and Primary completion rate (% of total enrollments) in Iran?
Your answer should be compact. -2.27. In the year 2013, what is the difference between the Primary completion rate (% of total enrollments) of Dominica and Primary completion rate (% of total enrollments) of Philippines?
Your answer should be very brief. 7. In the year 2013, what is the difference between the Primary completion rate (% of total enrollments) of Iran and Primary completion rate (% of total enrollments) of Philippines?
Provide a succinct answer. 9.27. What is the ratio of the Primary completion rate (% of total enrollments) of Belarus in 2003 to that in 2004?
Your answer should be compact. 1.02. What is the ratio of the Primary completion rate (% of total enrollments) of Dominica in 2003 to that in 2004?
Offer a terse response. 0.95. What is the ratio of the Primary completion rate (% of total enrollments) of Iran in 2003 to that in 2004?
Provide a succinct answer. 0.84. What is the ratio of the Primary completion rate (% of total enrollments) in Philippines in 2003 to that in 2004?
Make the answer very short. 1.02. What is the ratio of the Primary completion rate (% of total enrollments) in Belarus in 2003 to that in 2005?
Ensure brevity in your answer.  1.07. What is the ratio of the Primary completion rate (% of total enrollments) in Iran in 2003 to that in 2005?
Your answer should be very brief. 0.8. What is the ratio of the Primary completion rate (% of total enrollments) of Philippines in 2003 to that in 2005?
Offer a terse response. 1.01. What is the ratio of the Primary completion rate (% of total enrollments) of Belarus in 2003 to that in 2006?
Make the answer very short. 1.08. What is the ratio of the Primary completion rate (% of total enrollments) of Dominica in 2003 to that in 2006?
Make the answer very short. 1.04. What is the ratio of the Primary completion rate (% of total enrollments) of Iran in 2003 to that in 2006?
Give a very brief answer. 0.9. What is the ratio of the Primary completion rate (% of total enrollments) of Philippines in 2003 to that in 2006?
Offer a very short reply. 1.04. What is the ratio of the Primary completion rate (% of total enrollments) of Belarus in 2003 to that in 2007?
Give a very brief answer. 1.08. What is the ratio of the Primary completion rate (% of total enrollments) in Dominica in 2003 to that in 2007?
Give a very brief answer. 1.02. What is the ratio of the Primary completion rate (% of total enrollments) of Iran in 2003 to that in 2007?
Offer a terse response. 0.94. What is the ratio of the Primary completion rate (% of total enrollments) in Philippines in 2003 to that in 2007?
Ensure brevity in your answer.  1.05. What is the ratio of the Primary completion rate (% of total enrollments) of Belarus in 2003 to that in 2008?
Provide a short and direct response. 1.04. What is the ratio of the Primary completion rate (% of total enrollments) of Dominica in 2003 to that in 2008?
Your answer should be compact. 1.07. What is the ratio of the Primary completion rate (% of total enrollments) of Iran in 2003 to that in 2008?
Your answer should be very brief. 0.91. What is the ratio of the Primary completion rate (% of total enrollments) in Philippines in 2003 to that in 2008?
Keep it short and to the point. 1.04. What is the ratio of the Primary completion rate (% of total enrollments) in Belarus in 2003 to that in 2013?
Your answer should be very brief. 1.02. What is the ratio of the Primary completion rate (% of total enrollments) in Dominica in 2003 to that in 2013?
Your answer should be compact. 0.96. What is the ratio of the Primary completion rate (% of total enrollments) in Iran in 2003 to that in 2013?
Your answer should be compact. 0.85. What is the ratio of the Primary completion rate (% of total enrollments) of Philippines in 2003 to that in 2013?
Offer a very short reply. 1.04. What is the ratio of the Primary completion rate (% of total enrollments) in Belarus in 2004 to that in 2005?
Your answer should be very brief. 1.05. What is the ratio of the Primary completion rate (% of total enrollments) of Dominica in 2004 to that in 2005?
Offer a terse response. 0.98. What is the ratio of the Primary completion rate (% of total enrollments) in Iran in 2004 to that in 2005?
Ensure brevity in your answer.  0.95. What is the ratio of the Primary completion rate (% of total enrollments) in Belarus in 2004 to that in 2006?
Make the answer very short. 1.05. What is the ratio of the Primary completion rate (% of total enrollments) of Dominica in 2004 to that in 2006?
Provide a short and direct response. 1.1. What is the ratio of the Primary completion rate (% of total enrollments) in Iran in 2004 to that in 2006?
Your response must be concise. 1.08. What is the ratio of the Primary completion rate (% of total enrollments) in Philippines in 2004 to that in 2006?
Make the answer very short. 1.02. What is the ratio of the Primary completion rate (% of total enrollments) in Belarus in 2004 to that in 2007?
Your answer should be very brief. 1.06. What is the ratio of the Primary completion rate (% of total enrollments) in Dominica in 2004 to that in 2007?
Provide a short and direct response. 1.08. What is the ratio of the Primary completion rate (% of total enrollments) of Iran in 2004 to that in 2007?
Give a very brief answer. 1.12. What is the ratio of the Primary completion rate (% of total enrollments) in Belarus in 2004 to that in 2008?
Your response must be concise. 1.02. What is the ratio of the Primary completion rate (% of total enrollments) of Dominica in 2004 to that in 2008?
Ensure brevity in your answer.  1.13. What is the ratio of the Primary completion rate (% of total enrollments) in Iran in 2004 to that in 2008?
Your answer should be compact. 1.08. What is the ratio of the Primary completion rate (% of total enrollments) of Philippines in 2004 to that in 2008?
Offer a terse response. 1.03. What is the ratio of the Primary completion rate (% of total enrollments) in Dominica in 2004 to that in 2013?
Provide a succinct answer. 1.01. What is the ratio of the Primary completion rate (% of total enrollments) in Iran in 2004 to that in 2013?
Make the answer very short. 1.01. What is the ratio of the Primary completion rate (% of total enrollments) in Philippines in 2004 to that in 2013?
Make the answer very short. 1.02. What is the ratio of the Primary completion rate (% of total enrollments) in Belarus in 2005 to that in 2006?
Provide a short and direct response. 1.01. What is the ratio of the Primary completion rate (% of total enrollments) in Dominica in 2005 to that in 2006?
Provide a succinct answer. 1.12. What is the ratio of the Primary completion rate (% of total enrollments) of Iran in 2005 to that in 2006?
Provide a succinct answer. 1.14. What is the ratio of the Primary completion rate (% of total enrollments) of Philippines in 2005 to that in 2006?
Ensure brevity in your answer.  1.03. What is the ratio of the Primary completion rate (% of total enrollments) in Belarus in 2005 to that in 2007?
Your answer should be compact. 1.01. What is the ratio of the Primary completion rate (% of total enrollments) in Dominica in 2005 to that in 2007?
Your answer should be very brief. 1.1. What is the ratio of the Primary completion rate (% of total enrollments) of Iran in 2005 to that in 2007?
Your answer should be compact. 1.18. What is the ratio of the Primary completion rate (% of total enrollments) in Philippines in 2005 to that in 2007?
Ensure brevity in your answer.  1.04. What is the ratio of the Primary completion rate (% of total enrollments) in Belarus in 2005 to that in 2008?
Make the answer very short. 0.98. What is the ratio of the Primary completion rate (% of total enrollments) in Dominica in 2005 to that in 2008?
Keep it short and to the point. 1.15. What is the ratio of the Primary completion rate (% of total enrollments) of Iran in 2005 to that in 2008?
Ensure brevity in your answer.  1.14. What is the ratio of the Primary completion rate (% of total enrollments) of Philippines in 2005 to that in 2008?
Offer a very short reply. 1.03. What is the ratio of the Primary completion rate (% of total enrollments) in Belarus in 2005 to that in 2013?
Offer a terse response. 0.96. What is the ratio of the Primary completion rate (% of total enrollments) in Iran in 2005 to that in 2013?
Provide a short and direct response. 1.07. What is the ratio of the Primary completion rate (% of total enrollments) of Philippines in 2005 to that in 2013?
Your answer should be very brief. 1.02. What is the ratio of the Primary completion rate (% of total enrollments) in Dominica in 2006 to that in 2007?
Offer a very short reply. 0.98. What is the ratio of the Primary completion rate (% of total enrollments) of Iran in 2006 to that in 2007?
Your answer should be very brief. 1.04. What is the ratio of the Primary completion rate (% of total enrollments) of Philippines in 2006 to that in 2007?
Your answer should be very brief. 1.01. What is the ratio of the Primary completion rate (% of total enrollments) of Belarus in 2006 to that in 2008?
Make the answer very short. 0.97. What is the ratio of the Primary completion rate (% of total enrollments) in Dominica in 2006 to that in 2008?
Provide a succinct answer. 1.03. What is the ratio of the Primary completion rate (% of total enrollments) in Belarus in 2006 to that in 2013?
Your response must be concise. 0.95. What is the ratio of the Primary completion rate (% of total enrollments) of Dominica in 2006 to that in 2013?
Offer a terse response. 0.92. What is the ratio of the Primary completion rate (% of total enrollments) in Iran in 2006 to that in 2013?
Keep it short and to the point. 0.94. What is the ratio of the Primary completion rate (% of total enrollments) in Belarus in 2007 to that in 2008?
Your response must be concise. 0.96. What is the ratio of the Primary completion rate (% of total enrollments) in Dominica in 2007 to that in 2008?
Provide a succinct answer. 1.05. What is the ratio of the Primary completion rate (% of total enrollments) of Iran in 2007 to that in 2008?
Your answer should be very brief. 0.97. What is the ratio of the Primary completion rate (% of total enrollments) in Belarus in 2007 to that in 2013?
Offer a terse response. 0.95. What is the ratio of the Primary completion rate (% of total enrollments) in Dominica in 2007 to that in 2013?
Keep it short and to the point. 0.94. What is the ratio of the Primary completion rate (% of total enrollments) of Iran in 2007 to that in 2013?
Ensure brevity in your answer.  0.91. What is the ratio of the Primary completion rate (% of total enrollments) of Philippines in 2007 to that in 2013?
Offer a terse response. 0.99. What is the ratio of the Primary completion rate (% of total enrollments) of Belarus in 2008 to that in 2013?
Your response must be concise. 0.98. What is the ratio of the Primary completion rate (% of total enrollments) in Dominica in 2008 to that in 2013?
Provide a succinct answer. 0.9. What is the ratio of the Primary completion rate (% of total enrollments) of Iran in 2008 to that in 2013?
Keep it short and to the point. 0.94. What is the difference between the highest and the second highest Primary completion rate (% of total enrollments) in Belarus?
Ensure brevity in your answer.  2.06. What is the difference between the highest and the second highest Primary completion rate (% of total enrollments) of Dominica?
Keep it short and to the point. 2.33. What is the difference between the highest and the second highest Primary completion rate (% of total enrollments) of Iran?
Provide a short and direct response. 5.92. What is the difference between the highest and the second highest Primary completion rate (% of total enrollments) of Philippines?
Keep it short and to the point. 1.17. What is the difference between the highest and the lowest Primary completion rate (% of total enrollments) in Belarus?
Your answer should be very brief. 7.65. What is the difference between the highest and the lowest Primary completion rate (% of total enrollments) of Dominica?
Your answer should be very brief. 14.17. What is the difference between the highest and the lowest Primary completion rate (% of total enrollments) of Iran?
Your answer should be very brief. 22.87. What is the difference between the highest and the lowest Primary completion rate (% of total enrollments) in Philippines?
Your answer should be compact. 4.64. 